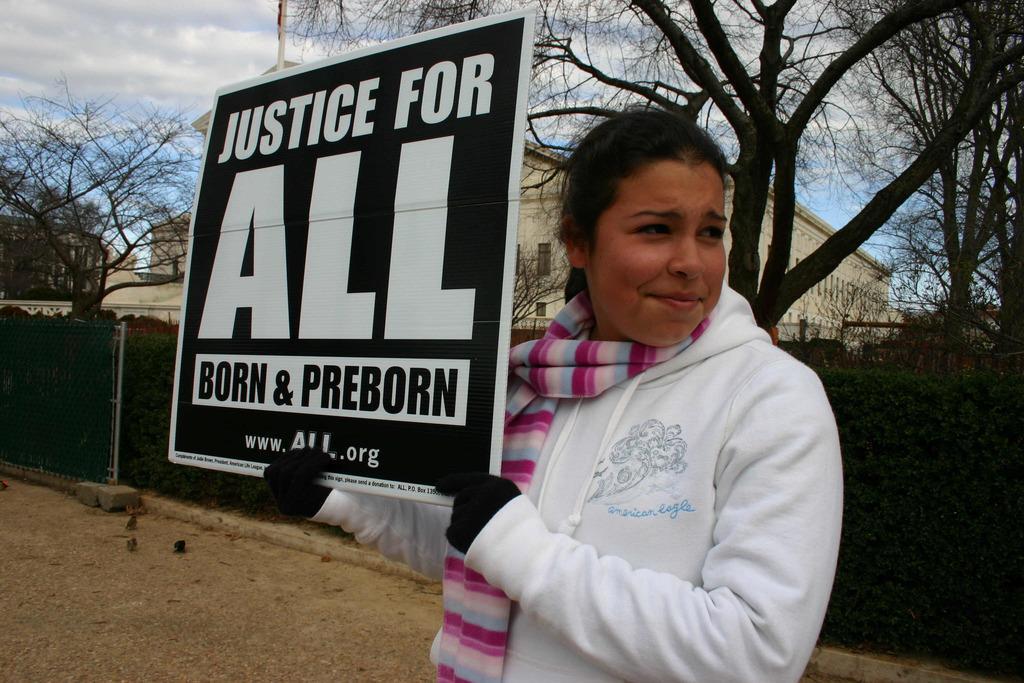Could you give a brief overview of what you see in this image? In this image there is a person standing and holding a board , and in the background there are plants, wire fence, buildings, trees, pole ,sky. 